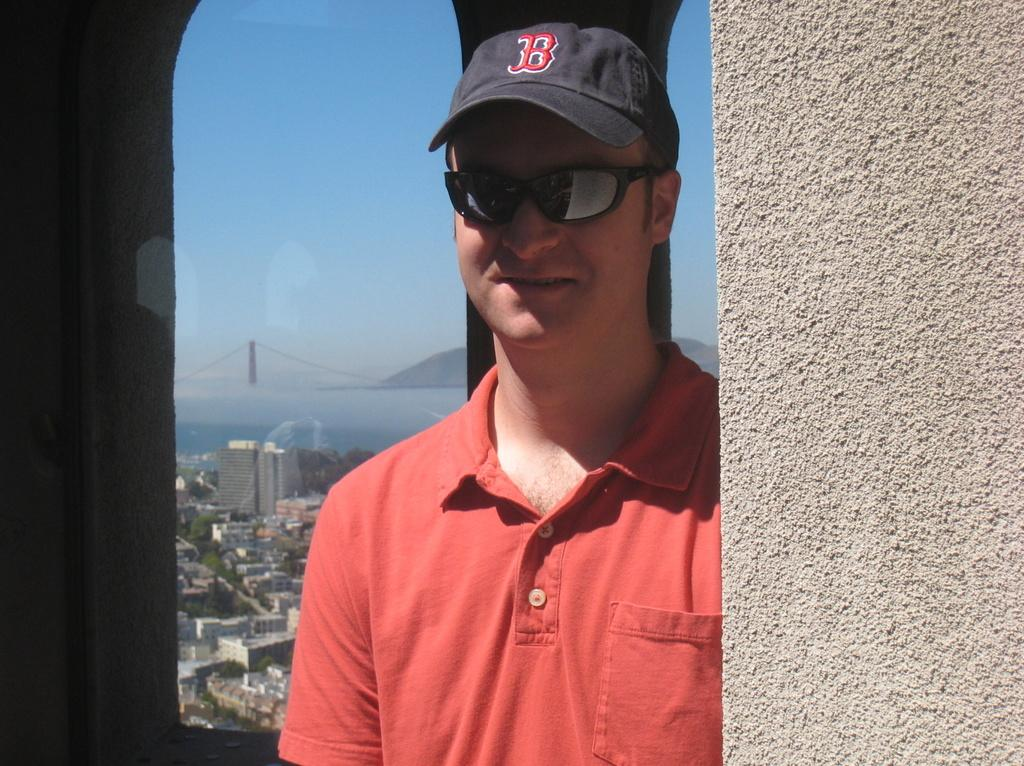What is the main subject of the image? There is a person in the image. What is the person wearing on their upper body? The person is wearing a red T-shirt. What protective gear is the person wearing? The person is wearing goggles. What type of headwear is the person wearing? The person is wearing a black cap. What can be seen in the background of the image? There are buildings and trees in the background of the image. What type of sugar is being used to cover the person's leg in the image? There is no sugar or leg visible in the image; the person is wearing a red T-shirt, goggles, and a black cap. 